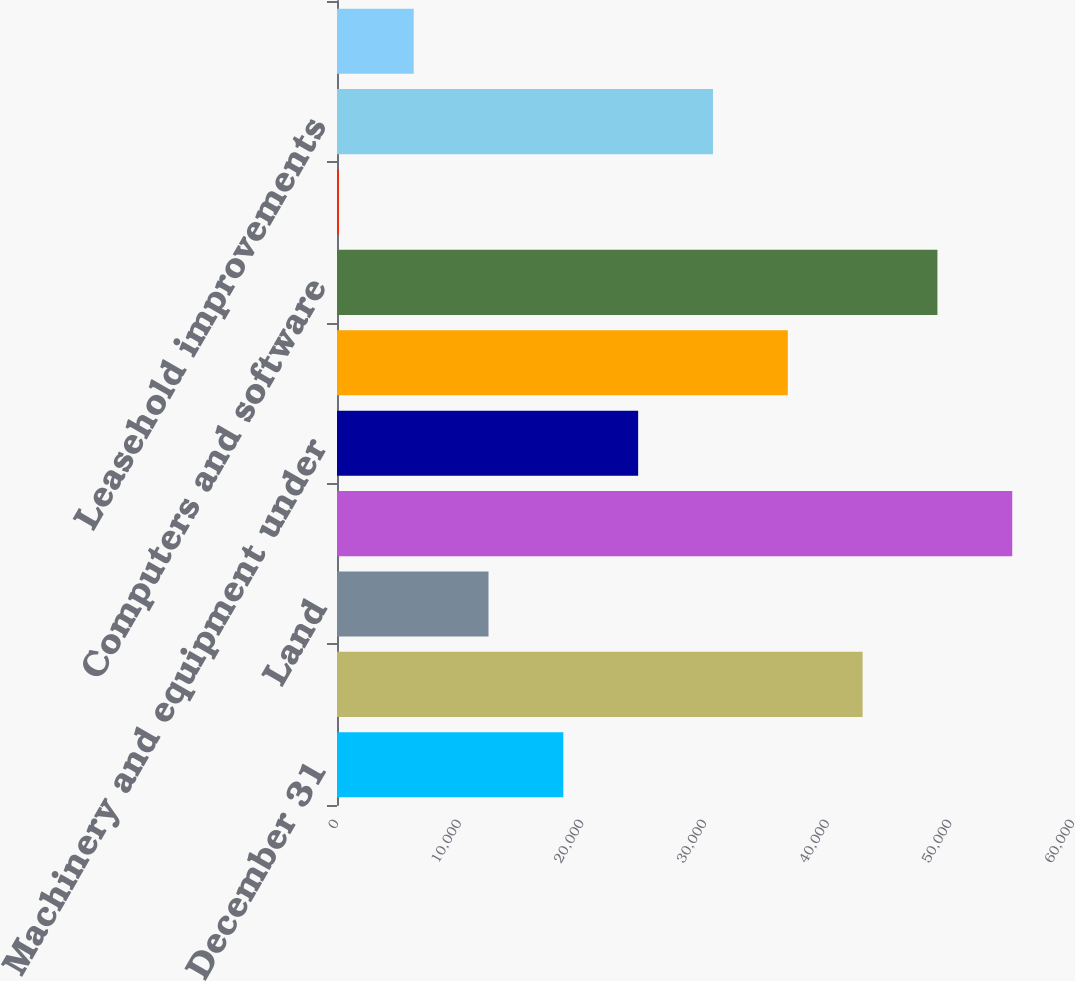<chart> <loc_0><loc_0><loc_500><loc_500><bar_chart><fcel>December 31<fcel>Buildings<fcel>Land<fcel>Machinery equipment and<fcel>Machinery and equipment under<fcel>Furniture and office equipment<fcel>Computers and software<fcel>Automobiles<fcel>Leasehold improvements<fcel>Projects in progress<nl><fcel>18451.2<fcel>42848.8<fcel>12351.8<fcel>55047.6<fcel>24550.6<fcel>36749.4<fcel>48948.2<fcel>153<fcel>30650<fcel>6252.4<nl></chart> 